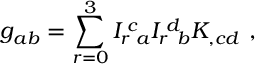Convert formula to latex. <formula><loc_0><loc_0><loc_500><loc_500>g _ { a b } = \sum _ { r = 0 } ^ { 3 } I _ { r } { \, } ^ { c } { \, } _ { a } I _ { r } { \, } ^ { d } { \, } _ { b } K _ { , c d } \ ,</formula> 